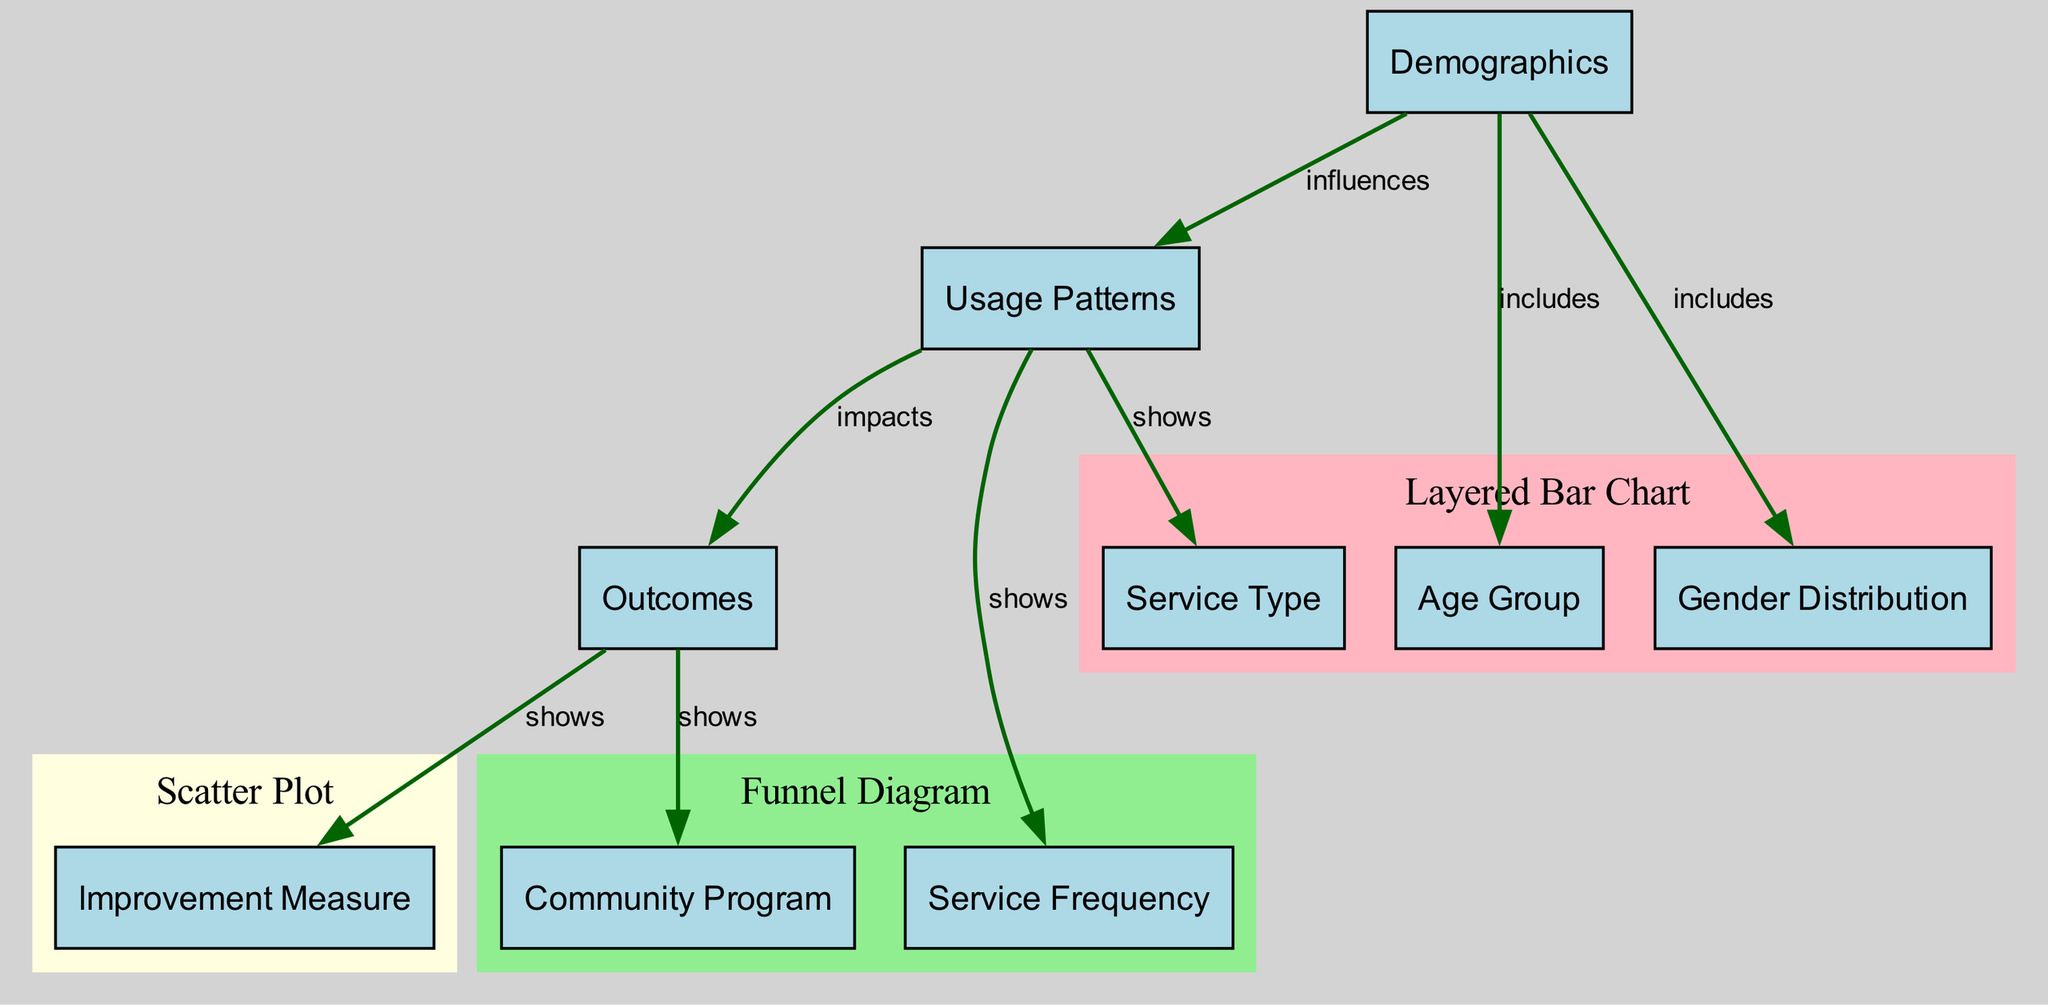What are the three main demographic components? The three main demographic components represented as nodes in the diagram are "age_group," "gender_distribution," and "service_type," which are all directly connected to the node "demographics."
Answer: age group, gender distribution, service type How many edges are shown in the diagram? The diagram includes a total of 7 edges that represent connections between nodes, which indicate relationships such as "influences," "shows," and "impacts."
Answer: 7 What does the "usage_patterns" node influence? The "usage_patterns" node influences the "outcomes" node, showing a direct connection in the flow of information throughout the diagram.
Answer: outcomes Which chart type shows the relationship between the age group and improvement measure? The "scatter_plot" chart type illustrates the relationship between "age_group" and "improvement_measure," highlighting how these elements are associated with each other.
Answer: scatter plot Which demographic detail represents the proportion of users by gender? The "gender_distribution" node specifically represents the proportion of users by gender among the demographic details in the diagram.
Answer: gender distribution What is the final element in the funnel diagram? The final element in the funnel diagram is "improvement_measure," which indicates the ultimate outcome or result after following the flow from service frequency and community program.
Answer: improvement measure Which nodes are part of the layered bar chart? The layered bar chart includes the nodes "age_group," "gender_distribution," and "service_type," showcasing these demographic details together.
Answer: age group, gender distribution, service type How do usage patterns impact outcomes? Usage patterns impact outcomes by showing how the frequency and types of services utilized can lead to specific results in mental health support provided by community organizations.
Answer: impacts Which community program measure is shown in relation to outcomes? The community program measure shown in relation to outcomes is connected through the "community_program" node, indicating its importance in assessing the impact of the services provided.
Answer: community program 